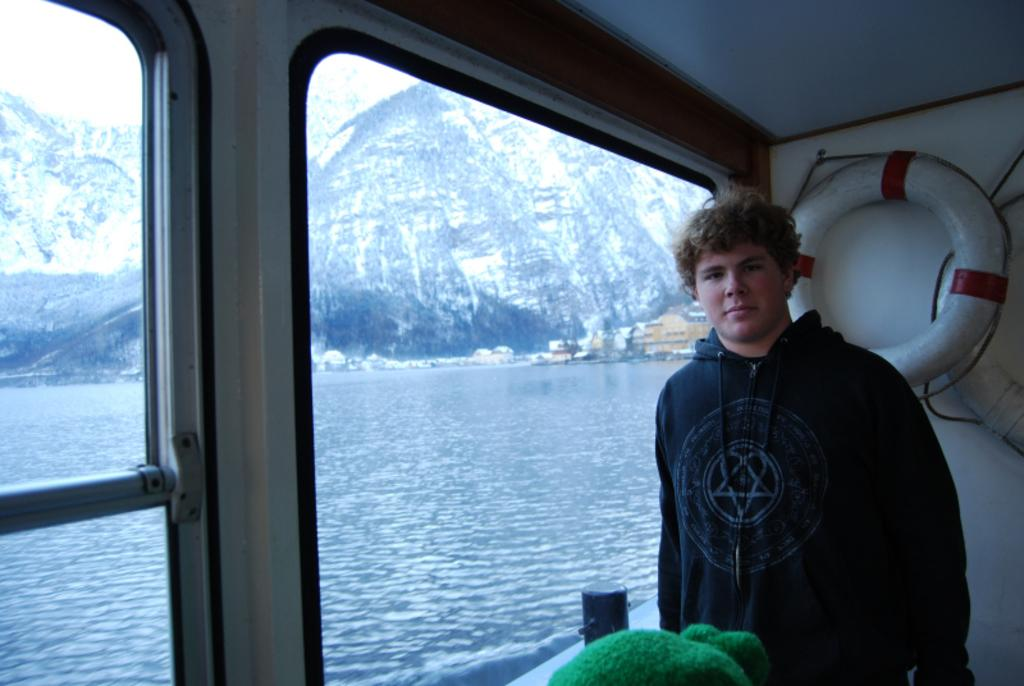What is the person in the image standing on? The person is standing in a ship. What type of landscape can be seen in the image? There are mountains visible in the image. What type of structures are present in the image? There are buildings in the image. What natural element is visible in the image? There is water visible in the image. What is visible above the ship and buildings? The sky is visible in the image. What type of whip is being used by the person in the image? There is no whip present in the image; the person is standing in a ship. What account number is associated with the ship in the image? There is no account number associated with the ship in the image; it is a visual representation of a person standing in a ship. 